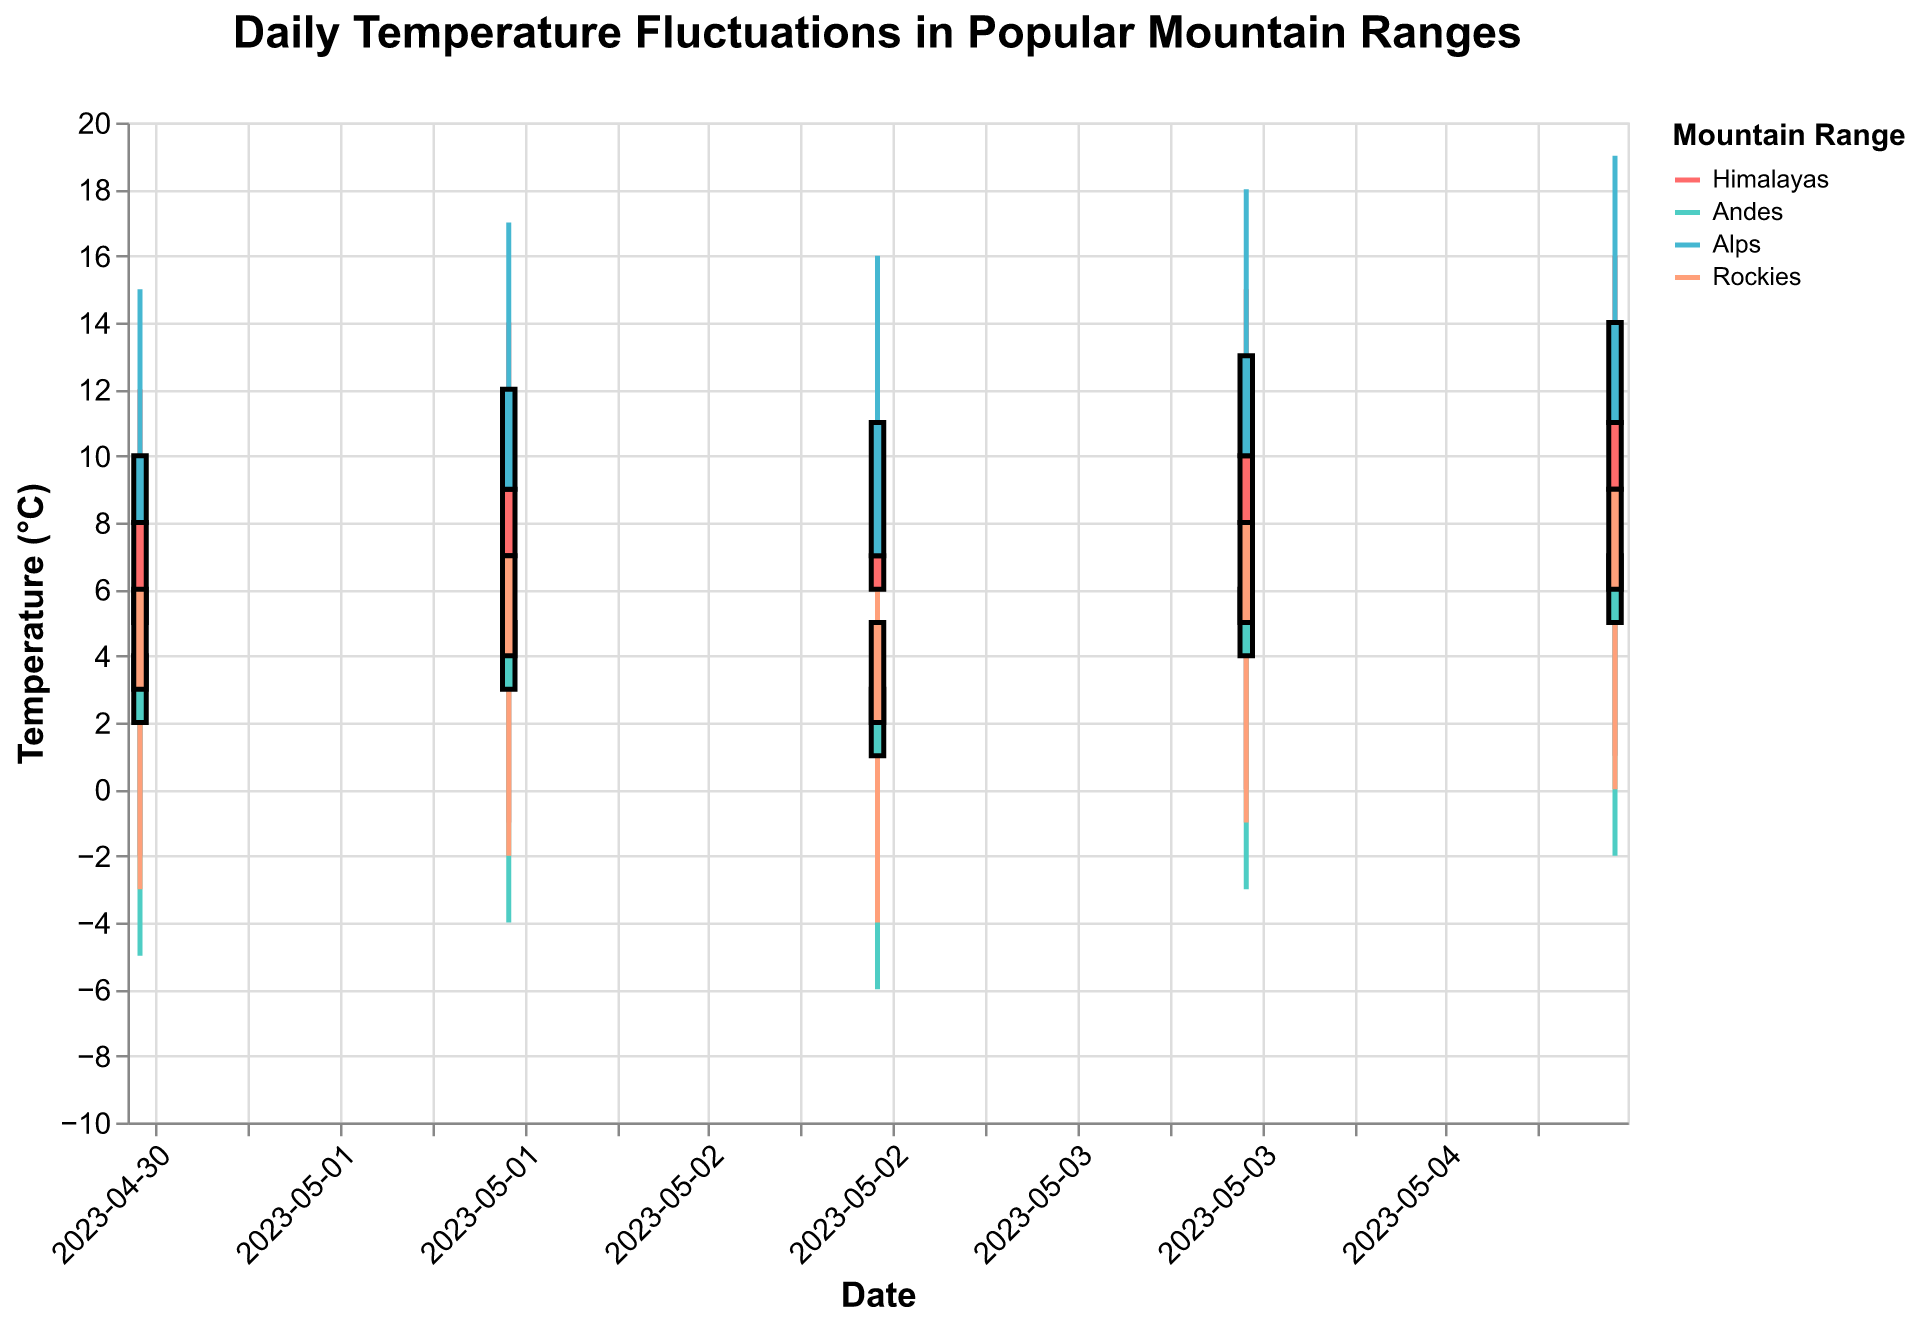What's the title of the figure? The title is written at the top of the figure and provides an overall description of what the chart represents.
Answer: Daily Temperature Fluctuations in Popular Mountain Ranges Which mountain range has the highest close temperature on 2023-05-05? By looking at the "Close" values for 2023-05-05, the highest value is 14°C, which corresponds to the Alps.
Answer: Alps What is the temperature range (High-Low) in the Andes on 2023-05-01? Subtract the Low value (-5) from the High value (9) from the Andes on 2023-05-01. The range is 9 - (-5) = 14°C.
Answer: 14°C Which mountain range has the most stable (smallest) temperature range on 2023-05-03? Compare the differences between the High and Low temperatures for each mountain range on 2023-05-03. The Andes has the smallest range of 8 - (-6) = 14°C.
Answer: Andes What's the average closing temperature for the Rockies across all the dates? Sum the closing temperatures for the Rockies (6, 7, 5, 8, 9) and divide by the number of dates (5). (6 + 7 + 5 + 8 + 9) / 5 = 35 / 5 = 7°C.
Answer: 7°C On which date did the Himalayas experience the lowest temperature? Identify the lowest 'Low' value for the Himalayas across the dates and see it's -3°C, occurring on 2023-05-03.
Answer: 2023-05-03 Which mountain range has the highest average high temperature over all the given dates? Calculate the average of the "High" values for each mountain range and compare them. The Alps have an average of (15+17+16+18+19)/5 = 85/5 = 17°C, which is the highest.
Answer: Alps What is the difference between the high temperatures in the Himalayas and the Andes on 2023-05-02? Subtract the high temperature of the Andes (11°C) from that of the Himalayas (14°C) on 2023-05-02. 14 - 11 = 3°C.
Answer: 3°C On which date did the Rockies experience the greatest temperature fluctuation? Calculate the High-Low for each date and compare. The fluctuation was greatest on 2023-05-01 and 2023-05-05, both having a fluctuation of 14 - 0 = 14°C.
Answer: 2023-05-01 and 2023-05-05 